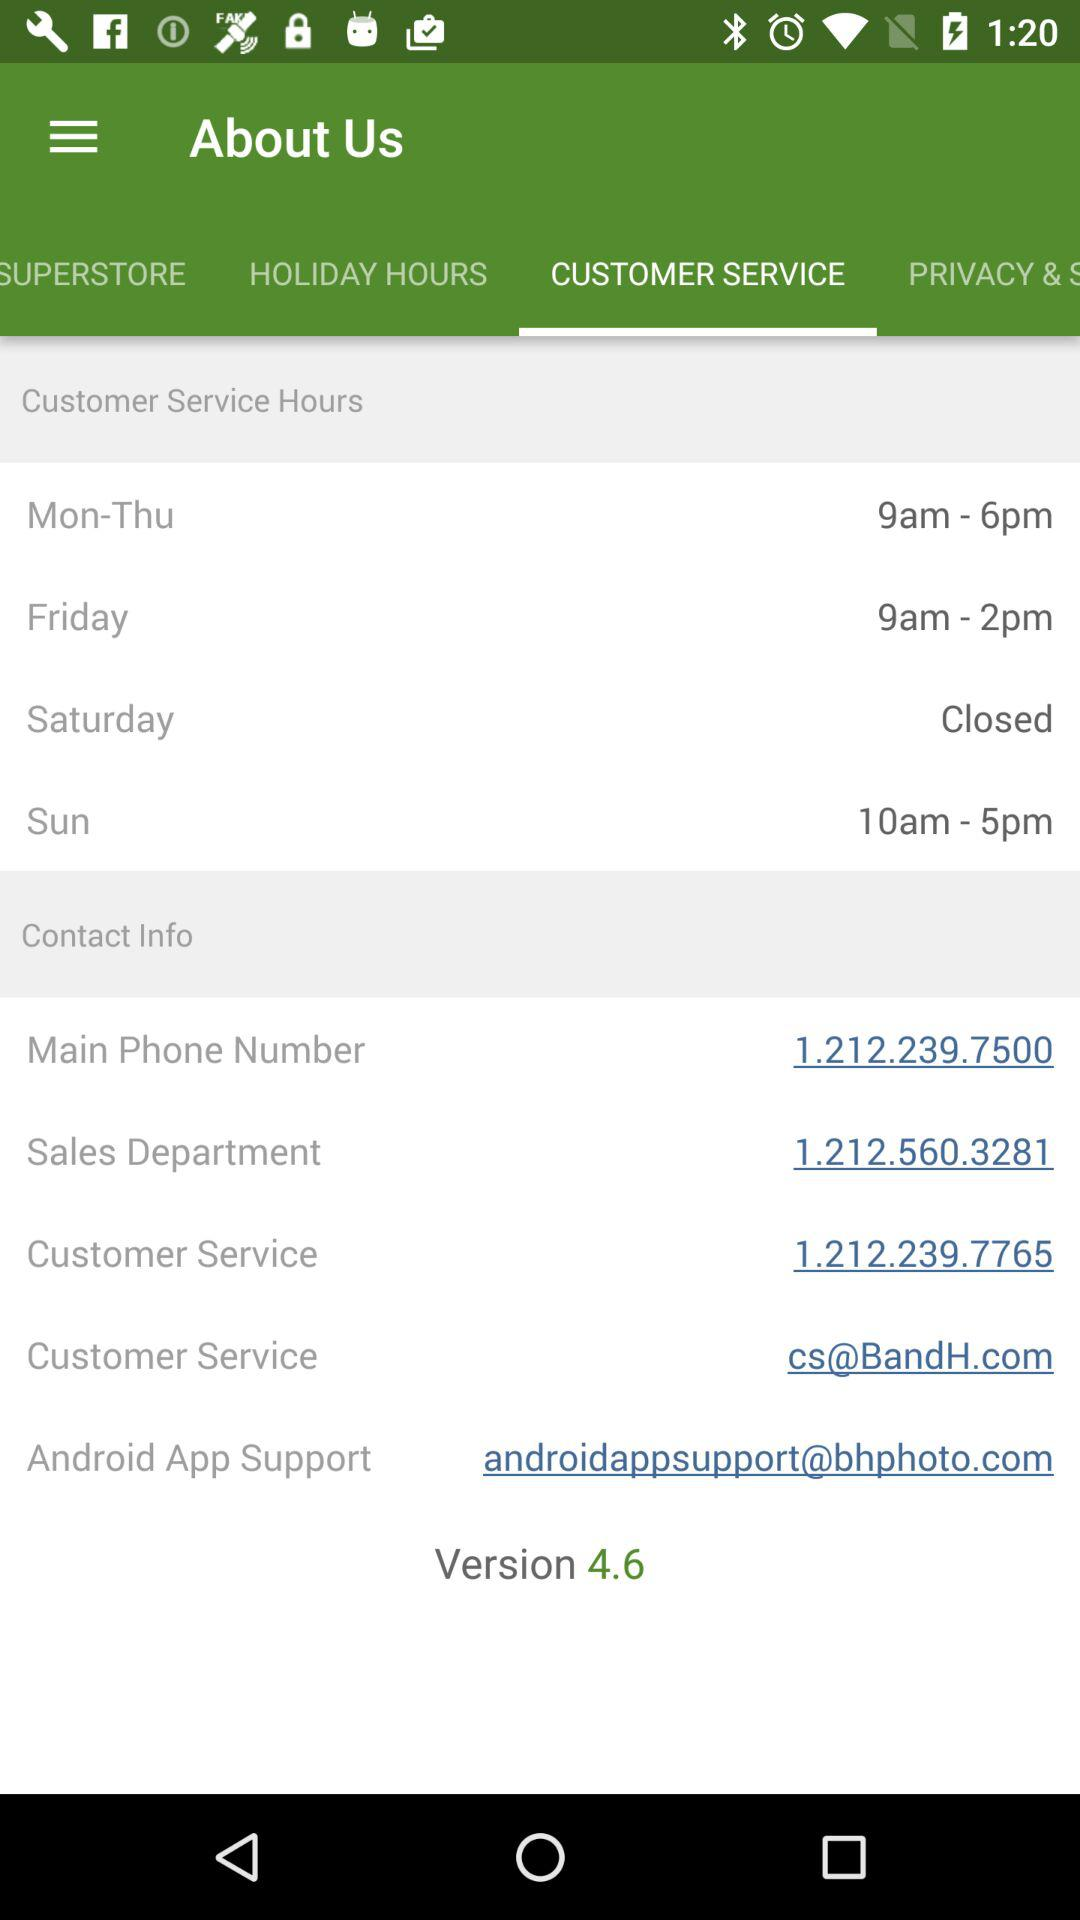What is the version number? The version number is 4.6. 